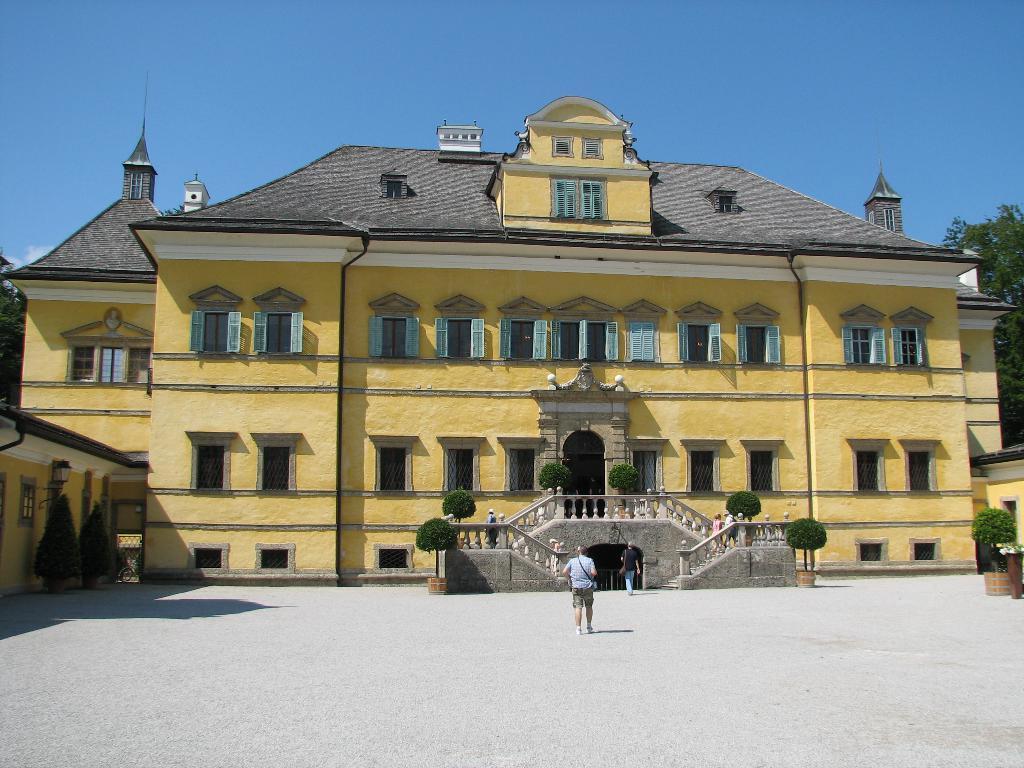Describe this image in one or two sentences. In the foreground of the picture it is a pavement, there is a person walking. In the center of the picture there are plants and a building. On the right there is a tree. On the left there is a tree. On the top it is sky. 